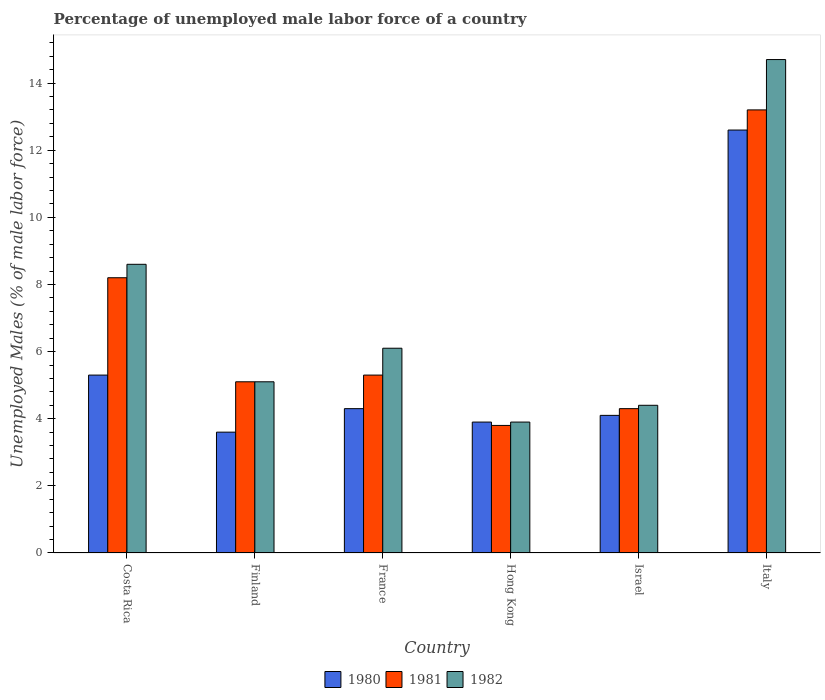Are the number of bars per tick equal to the number of legend labels?
Give a very brief answer. Yes. How many bars are there on the 5th tick from the left?
Offer a very short reply. 3. What is the percentage of unemployed male labor force in 1982 in France?
Your answer should be very brief. 6.1. Across all countries, what is the maximum percentage of unemployed male labor force in 1981?
Your answer should be compact. 13.2. Across all countries, what is the minimum percentage of unemployed male labor force in 1981?
Offer a terse response. 3.8. In which country was the percentage of unemployed male labor force in 1981 minimum?
Your answer should be compact. Hong Kong. What is the total percentage of unemployed male labor force in 1980 in the graph?
Your answer should be compact. 33.8. What is the difference between the percentage of unemployed male labor force in 1980 in France and that in Israel?
Offer a very short reply. 0.2. What is the difference between the percentage of unemployed male labor force in 1982 in Finland and the percentage of unemployed male labor force in 1980 in France?
Your response must be concise. 0.8. What is the average percentage of unemployed male labor force in 1981 per country?
Your answer should be very brief. 6.65. What is the difference between the percentage of unemployed male labor force of/in 1982 and percentage of unemployed male labor force of/in 1981 in France?
Your response must be concise. 0.8. What is the ratio of the percentage of unemployed male labor force in 1982 in Finland to that in Italy?
Provide a short and direct response. 0.35. What is the difference between the highest and the second highest percentage of unemployed male labor force in 1982?
Your answer should be very brief. -6.1. What is the difference between the highest and the lowest percentage of unemployed male labor force in 1981?
Provide a succinct answer. 9.4. In how many countries, is the percentage of unemployed male labor force in 1982 greater than the average percentage of unemployed male labor force in 1982 taken over all countries?
Keep it short and to the point. 2. Is the sum of the percentage of unemployed male labor force in 1982 in France and Hong Kong greater than the maximum percentage of unemployed male labor force in 1981 across all countries?
Your answer should be very brief. No. What does the 1st bar from the left in Israel represents?
Keep it short and to the point. 1980. How many bars are there?
Offer a terse response. 18. Are all the bars in the graph horizontal?
Your answer should be compact. No. What is the difference between two consecutive major ticks on the Y-axis?
Ensure brevity in your answer.  2. Does the graph contain any zero values?
Your response must be concise. No. Does the graph contain grids?
Ensure brevity in your answer.  No. How are the legend labels stacked?
Keep it short and to the point. Horizontal. What is the title of the graph?
Offer a terse response. Percentage of unemployed male labor force of a country. What is the label or title of the X-axis?
Offer a terse response. Country. What is the label or title of the Y-axis?
Your response must be concise. Unemployed Males (% of male labor force). What is the Unemployed Males (% of male labor force) of 1980 in Costa Rica?
Provide a succinct answer. 5.3. What is the Unemployed Males (% of male labor force) of 1981 in Costa Rica?
Provide a succinct answer. 8.2. What is the Unemployed Males (% of male labor force) of 1982 in Costa Rica?
Make the answer very short. 8.6. What is the Unemployed Males (% of male labor force) in 1980 in Finland?
Your answer should be compact. 3.6. What is the Unemployed Males (% of male labor force) of 1981 in Finland?
Make the answer very short. 5.1. What is the Unemployed Males (% of male labor force) in 1982 in Finland?
Give a very brief answer. 5.1. What is the Unemployed Males (% of male labor force) in 1980 in France?
Offer a terse response. 4.3. What is the Unemployed Males (% of male labor force) in 1981 in France?
Offer a terse response. 5.3. What is the Unemployed Males (% of male labor force) of 1982 in France?
Ensure brevity in your answer.  6.1. What is the Unemployed Males (% of male labor force) in 1980 in Hong Kong?
Offer a terse response. 3.9. What is the Unemployed Males (% of male labor force) in 1981 in Hong Kong?
Your answer should be very brief. 3.8. What is the Unemployed Males (% of male labor force) of 1982 in Hong Kong?
Your answer should be very brief. 3.9. What is the Unemployed Males (% of male labor force) in 1980 in Israel?
Make the answer very short. 4.1. What is the Unemployed Males (% of male labor force) in 1981 in Israel?
Ensure brevity in your answer.  4.3. What is the Unemployed Males (% of male labor force) in 1982 in Israel?
Offer a very short reply. 4.4. What is the Unemployed Males (% of male labor force) in 1980 in Italy?
Keep it short and to the point. 12.6. What is the Unemployed Males (% of male labor force) in 1981 in Italy?
Your response must be concise. 13.2. What is the Unemployed Males (% of male labor force) of 1982 in Italy?
Your answer should be compact. 14.7. Across all countries, what is the maximum Unemployed Males (% of male labor force) of 1980?
Offer a terse response. 12.6. Across all countries, what is the maximum Unemployed Males (% of male labor force) in 1981?
Offer a very short reply. 13.2. Across all countries, what is the maximum Unemployed Males (% of male labor force) of 1982?
Your answer should be very brief. 14.7. Across all countries, what is the minimum Unemployed Males (% of male labor force) in 1980?
Give a very brief answer. 3.6. Across all countries, what is the minimum Unemployed Males (% of male labor force) in 1981?
Your answer should be very brief. 3.8. Across all countries, what is the minimum Unemployed Males (% of male labor force) of 1982?
Make the answer very short. 3.9. What is the total Unemployed Males (% of male labor force) in 1980 in the graph?
Offer a very short reply. 33.8. What is the total Unemployed Males (% of male labor force) in 1981 in the graph?
Keep it short and to the point. 39.9. What is the total Unemployed Males (% of male labor force) of 1982 in the graph?
Provide a succinct answer. 42.8. What is the difference between the Unemployed Males (% of male labor force) in 1980 in Costa Rica and that in Finland?
Your answer should be very brief. 1.7. What is the difference between the Unemployed Males (% of male labor force) in 1982 in Costa Rica and that in Finland?
Your answer should be very brief. 3.5. What is the difference between the Unemployed Males (% of male labor force) of 1981 in Costa Rica and that in Hong Kong?
Keep it short and to the point. 4.4. What is the difference between the Unemployed Males (% of male labor force) of 1980 in Costa Rica and that in Israel?
Offer a terse response. 1.2. What is the difference between the Unemployed Males (% of male labor force) in 1982 in Costa Rica and that in Israel?
Provide a succinct answer. 4.2. What is the difference between the Unemployed Males (% of male labor force) in 1980 in Costa Rica and that in Italy?
Offer a terse response. -7.3. What is the difference between the Unemployed Males (% of male labor force) in 1981 in Costa Rica and that in Italy?
Ensure brevity in your answer.  -5. What is the difference between the Unemployed Males (% of male labor force) of 1981 in Finland and that in France?
Make the answer very short. -0.2. What is the difference between the Unemployed Males (% of male labor force) in 1980 in Finland and that in Hong Kong?
Ensure brevity in your answer.  -0.3. What is the difference between the Unemployed Males (% of male labor force) of 1982 in Finland and that in Hong Kong?
Your answer should be compact. 1.2. What is the difference between the Unemployed Males (% of male labor force) of 1981 in Finland and that in Israel?
Your answer should be compact. 0.8. What is the difference between the Unemployed Males (% of male labor force) in 1982 in Finland and that in Israel?
Provide a short and direct response. 0.7. What is the difference between the Unemployed Males (% of male labor force) of 1980 in Finland and that in Italy?
Your answer should be compact. -9. What is the difference between the Unemployed Males (% of male labor force) in 1981 in France and that in Hong Kong?
Provide a short and direct response. 1.5. What is the difference between the Unemployed Males (% of male labor force) in 1980 in France and that in Israel?
Your answer should be very brief. 0.2. What is the difference between the Unemployed Males (% of male labor force) of 1980 in France and that in Italy?
Keep it short and to the point. -8.3. What is the difference between the Unemployed Males (% of male labor force) of 1981 in France and that in Italy?
Keep it short and to the point. -7.9. What is the difference between the Unemployed Males (% of male labor force) of 1981 in Hong Kong and that in Israel?
Offer a terse response. -0.5. What is the difference between the Unemployed Males (% of male labor force) in 1980 in Hong Kong and that in Italy?
Your response must be concise. -8.7. What is the difference between the Unemployed Males (% of male labor force) of 1981 in Hong Kong and that in Italy?
Your answer should be compact. -9.4. What is the difference between the Unemployed Males (% of male labor force) of 1981 in Israel and that in Italy?
Ensure brevity in your answer.  -8.9. What is the difference between the Unemployed Males (% of male labor force) of 1980 in Costa Rica and the Unemployed Males (% of male labor force) of 1982 in Finland?
Make the answer very short. 0.2. What is the difference between the Unemployed Males (% of male labor force) of 1980 in Costa Rica and the Unemployed Males (% of male labor force) of 1981 in France?
Provide a short and direct response. 0. What is the difference between the Unemployed Males (% of male labor force) in 1981 in Costa Rica and the Unemployed Males (% of male labor force) in 1982 in France?
Provide a short and direct response. 2.1. What is the difference between the Unemployed Males (% of male labor force) of 1980 in Costa Rica and the Unemployed Males (% of male labor force) of 1982 in Hong Kong?
Your answer should be very brief. 1.4. What is the difference between the Unemployed Males (% of male labor force) in 1981 in Costa Rica and the Unemployed Males (% of male labor force) in 1982 in Hong Kong?
Provide a short and direct response. 4.3. What is the difference between the Unemployed Males (% of male labor force) in 1980 in Costa Rica and the Unemployed Males (% of male labor force) in 1981 in Israel?
Provide a short and direct response. 1. What is the difference between the Unemployed Males (% of male labor force) of 1980 in Costa Rica and the Unemployed Males (% of male labor force) of 1982 in Israel?
Ensure brevity in your answer.  0.9. What is the difference between the Unemployed Males (% of male labor force) in 1980 in Costa Rica and the Unemployed Males (% of male labor force) in 1982 in Italy?
Ensure brevity in your answer.  -9.4. What is the difference between the Unemployed Males (% of male labor force) of 1981 in Costa Rica and the Unemployed Males (% of male labor force) of 1982 in Italy?
Offer a terse response. -6.5. What is the difference between the Unemployed Males (% of male labor force) in 1980 in Finland and the Unemployed Males (% of male labor force) in 1981 in France?
Give a very brief answer. -1.7. What is the difference between the Unemployed Males (% of male labor force) in 1980 in Finland and the Unemployed Males (% of male labor force) in 1982 in France?
Your answer should be very brief. -2.5. What is the difference between the Unemployed Males (% of male labor force) in 1980 in Finland and the Unemployed Males (% of male labor force) in 1981 in Hong Kong?
Your answer should be very brief. -0.2. What is the difference between the Unemployed Males (% of male labor force) of 1980 in Finland and the Unemployed Males (% of male labor force) of 1982 in Hong Kong?
Make the answer very short. -0.3. What is the difference between the Unemployed Males (% of male labor force) of 1980 in Finland and the Unemployed Males (% of male labor force) of 1981 in Israel?
Keep it short and to the point. -0.7. What is the difference between the Unemployed Males (% of male labor force) in 1980 in Finland and the Unemployed Males (% of male labor force) in 1982 in Israel?
Your answer should be compact. -0.8. What is the difference between the Unemployed Males (% of male labor force) of 1980 in Finland and the Unemployed Males (% of male labor force) of 1981 in Italy?
Offer a very short reply. -9.6. What is the difference between the Unemployed Males (% of male labor force) in 1980 in France and the Unemployed Males (% of male labor force) in 1981 in Hong Kong?
Provide a succinct answer. 0.5. What is the difference between the Unemployed Males (% of male labor force) of 1980 in France and the Unemployed Males (% of male labor force) of 1982 in Hong Kong?
Keep it short and to the point. 0.4. What is the difference between the Unemployed Males (% of male labor force) in 1981 in France and the Unemployed Males (% of male labor force) in 1982 in Hong Kong?
Keep it short and to the point. 1.4. What is the difference between the Unemployed Males (% of male labor force) of 1980 in France and the Unemployed Males (% of male labor force) of 1981 in Israel?
Provide a short and direct response. 0. What is the difference between the Unemployed Males (% of male labor force) of 1980 in France and the Unemployed Males (% of male labor force) of 1982 in Israel?
Make the answer very short. -0.1. What is the difference between the Unemployed Males (% of male labor force) of 1980 in France and the Unemployed Males (% of male labor force) of 1981 in Italy?
Your answer should be compact. -8.9. What is the difference between the Unemployed Males (% of male labor force) in 1980 in Hong Kong and the Unemployed Males (% of male labor force) in 1981 in Israel?
Your response must be concise. -0.4. What is the difference between the Unemployed Males (% of male labor force) in 1980 in Hong Kong and the Unemployed Males (% of male labor force) in 1982 in Israel?
Your answer should be compact. -0.5. What is the difference between the Unemployed Males (% of male labor force) in 1981 in Hong Kong and the Unemployed Males (% of male labor force) in 1982 in Italy?
Give a very brief answer. -10.9. What is the difference between the Unemployed Males (% of male labor force) of 1980 in Israel and the Unemployed Males (% of male labor force) of 1982 in Italy?
Provide a short and direct response. -10.6. What is the average Unemployed Males (% of male labor force) of 1980 per country?
Keep it short and to the point. 5.63. What is the average Unemployed Males (% of male labor force) of 1981 per country?
Your response must be concise. 6.65. What is the average Unemployed Males (% of male labor force) of 1982 per country?
Your response must be concise. 7.13. What is the difference between the Unemployed Males (% of male labor force) of 1980 and Unemployed Males (% of male labor force) of 1981 in Costa Rica?
Offer a terse response. -2.9. What is the difference between the Unemployed Males (% of male labor force) of 1980 and Unemployed Males (% of male labor force) of 1982 in Costa Rica?
Keep it short and to the point. -3.3. What is the difference between the Unemployed Males (% of male labor force) in 1980 and Unemployed Males (% of male labor force) in 1982 in Finland?
Ensure brevity in your answer.  -1.5. What is the difference between the Unemployed Males (% of male labor force) of 1981 and Unemployed Males (% of male labor force) of 1982 in Finland?
Make the answer very short. 0. What is the difference between the Unemployed Males (% of male labor force) of 1980 and Unemployed Males (% of male labor force) of 1981 in France?
Provide a succinct answer. -1. What is the difference between the Unemployed Males (% of male labor force) in 1980 and Unemployed Males (% of male labor force) in 1982 in France?
Provide a succinct answer. -1.8. What is the difference between the Unemployed Males (% of male labor force) in 1980 and Unemployed Males (% of male labor force) in 1981 in Hong Kong?
Offer a very short reply. 0.1. What is the difference between the Unemployed Males (% of male labor force) in 1980 and Unemployed Males (% of male labor force) in 1982 in Israel?
Give a very brief answer. -0.3. What is the difference between the Unemployed Males (% of male labor force) of 1981 and Unemployed Males (% of male labor force) of 1982 in Israel?
Give a very brief answer. -0.1. What is the difference between the Unemployed Males (% of male labor force) in 1980 and Unemployed Males (% of male labor force) in 1981 in Italy?
Offer a terse response. -0.6. What is the difference between the Unemployed Males (% of male labor force) of 1981 and Unemployed Males (% of male labor force) of 1982 in Italy?
Provide a succinct answer. -1.5. What is the ratio of the Unemployed Males (% of male labor force) in 1980 in Costa Rica to that in Finland?
Ensure brevity in your answer.  1.47. What is the ratio of the Unemployed Males (% of male labor force) in 1981 in Costa Rica to that in Finland?
Offer a very short reply. 1.61. What is the ratio of the Unemployed Males (% of male labor force) in 1982 in Costa Rica to that in Finland?
Give a very brief answer. 1.69. What is the ratio of the Unemployed Males (% of male labor force) of 1980 in Costa Rica to that in France?
Your answer should be compact. 1.23. What is the ratio of the Unemployed Males (% of male labor force) in 1981 in Costa Rica to that in France?
Your response must be concise. 1.55. What is the ratio of the Unemployed Males (% of male labor force) of 1982 in Costa Rica to that in France?
Provide a short and direct response. 1.41. What is the ratio of the Unemployed Males (% of male labor force) of 1980 in Costa Rica to that in Hong Kong?
Ensure brevity in your answer.  1.36. What is the ratio of the Unemployed Males (% of male labor force) of 1981 in Costa Rica to that in Hong Kong?
Your answer should be compact. 2.16. What is the ratio of the Unemployed Males (% of male labor force) of 1982 in Costa Rica to that in Hong Kong?
Offer a terse response. 2.21. What is the ratio of the Unemployed Males (% of male labor force) in 1980 in Costa Rica to that in Israel?
Keep it short and to the point. 1.29. What is the ratio of the Unemployed Males (% of male labor force) in 1981 in Costa Rica to that in Israel?
Make the answer very short. 1.91. What is the ratio of the Unemployed Males (% of male labor force) of 1982 in Costa Rica to that in Israel?
Your answer should be very brief. 1.95. What is the ratio of the Unemployed Males (% of male labor force) in 1980 in Costa Rica to that in Italy?
Give a very brief answer. 0.42. What is the ratio of the Unemployed Males (% of male labor force) of 1981 in Costa Rica to that in Italy?
Offer a very short reply. 0.62. What is the ratio of the Unemployed Males (% of male labor force) in 1982 in Costa Rica to that in Italy?
Provide a succinct answer. 0.58. What is the ratio of the Unemployed Males (% of male labor force) of 1980 in Finland to that in France?
Offer a terse response. 0.84. What is the ratio of the Unemployed Males (% of male labor force) of 1981 in Finland to that in France?
Give a very brief answer. 0.96. What is the ratio of the Unemployed Males (% of male labor force) of 1982 in Finland to that in France?
Provide a short and direct response. 0.84. What is the ratio of the Unemployed Males (% of male labor force) of 1981 in Finland to that in Hong Kong?
Provide a short and direct response. 1.34. What is the ratio of the Unemployed Males (% of male labor force) of 1982 in Finland to that in Hong Kong?
Your response must be concise. 1.31. What is the ratio of the Unemployed Males (% of male labor force) of 1980 in Finland to that in Israel?
Your answer should be compact. 0.88. What is the ratio of the Unemployed Males (% of male labor force) in 1981 in Finland to that in Israel?
Keep it short and to the point. 1.19. What is the ratio of the Unemployed Males (% of male labor force) of 1982 in Finland to that in Israel?
Provide a short and direct response. 1.16. What is the ratio of the Unemployed Males (% of male labor force) in 1980 in Finland to that in Italy?
Keep it short and to the point. 0.29. What is the ratio of the Unemployed Males (% of male labor force) in 1981 in Finland to that in Italy?
Make the answer very short. 0.39. What is the ratio of the Unemployed Males (% of male labor force) in 1982 in Finland to that in Italy?
Your response must be concise. 0.35. What is the ratio of the Unemployed Males (% of male labor force) in 1980 in France to that in Hong Kong?
Your answer should be compact. 1.1. What is the ratio of the Unemployed Males (% of male labor force) in 1981 in France to that in Hong Kong?
Your answer should be compact. 1.39. What is the ratio of the Unemployed Males (% of male labor force) in 1982 in France to that in Hong Kong?
Offer a terse response. 1.56. What is the ratio of the Unemployed Males (% of male labor force) in 1980 in France to that in Israel?
Offer a terse response. 1.05. What is the ratio of the Unemployed Males (% of male labor force) of 1981 in France to that in Israel?
Your answer should be compact. 1.23. What is the ratio of the Unemployed Males (% of male labor force) of 1982 in France to that in Israel?
Offer a very short reply. 1.39. What is the ratio of the Unemployed Males (% of male labor force) in 1980 in France to that in Italy?
Provide a succinct answer. 0.34. What is the ratio of the Unemployed Males (% of male labor force) in 1981 in France to that in Italy?
Give a very brief answer. 0.4. What is the ratio of the Unemployed Males (% of male labor force) of 1982 in France to that in Italy?
Your response must be concise. 0.41. What is the ratio of the Unemployed Males (% of male labor force) in 1980 in Hong Kong to that in Israel?
Your response must be concise. 0.95. What is the ratio of the Unemployed Males (% of male labor force) in 1981 in Hong Kong to that in Israel?
Offer a very short reply. 0.88. What is the ratio of the Unemployed Males (% of male labor force) of 1982 in Hong Kong to that in Israel?
Make the answer very short. 0.89. What is the ratio of the Unemployed Males (% of male labor force) of 1980 in Hong Kong to that in Italy?
Your answer should be very brief. 0.31. What is the ratio of the Unemployed Males (% of male labor force) in 1981 in Hong Kong to that in Italy?
Provide a succinct answer. 0.29. What is the ratio of the Unemployed Males (% of male labor force) in 1982 in Hong Kong to that in Italy?
Make the answer very short. 0.27. What is the ratio of the Unemployed Males (% of male labor force) in 1980 in Israel to that in Italy?
Ensure brevity in your answer.  0.33. What is the ratio of the Unemployed Males (% of male labor force) in 1981 in Israel to that in Italy?
Ensure brevity in your answer.  0.33. What is the ratio of the Unemployed Males (% of male labor force) of 1982 in Israel to that in Italy?
Make the answer very short. 0.3. What is the difference between the highest and the second highest Unemployed Males (% of male labor force) of 1981?
Your answer should be compact. 5. What is the difference between the highest and the lowest Unemployed Males (% of male labor force) of 1981?
Provide a short and direct response. 9.4. 